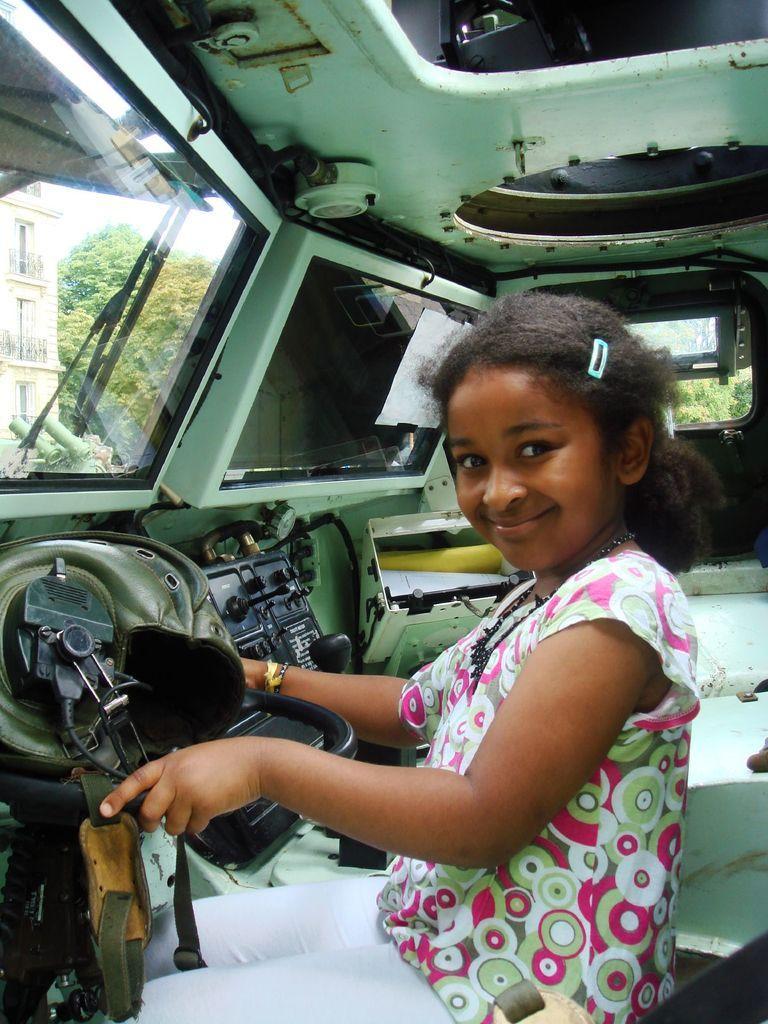Describe this image in one or two sentences. In this picture there is a small girl in the center of the image, it seems to be she is sitting inside a vehicle and there is a building and trees outside the vehicle. 